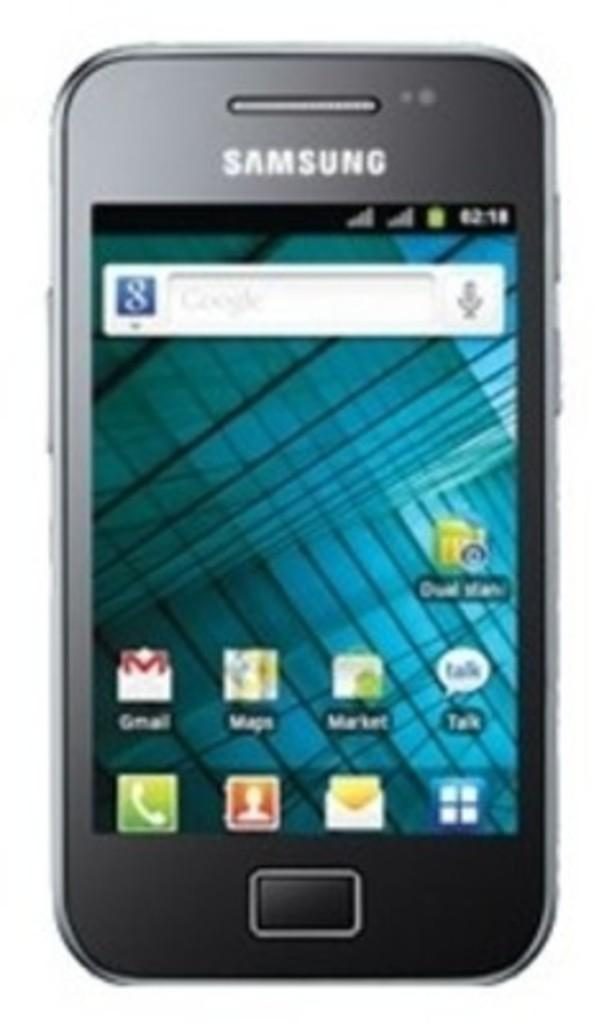<image>
Write a terse but informative summary of the picture. A Samsung phone showing icons near the bottom of the screen and Google search at the top. 